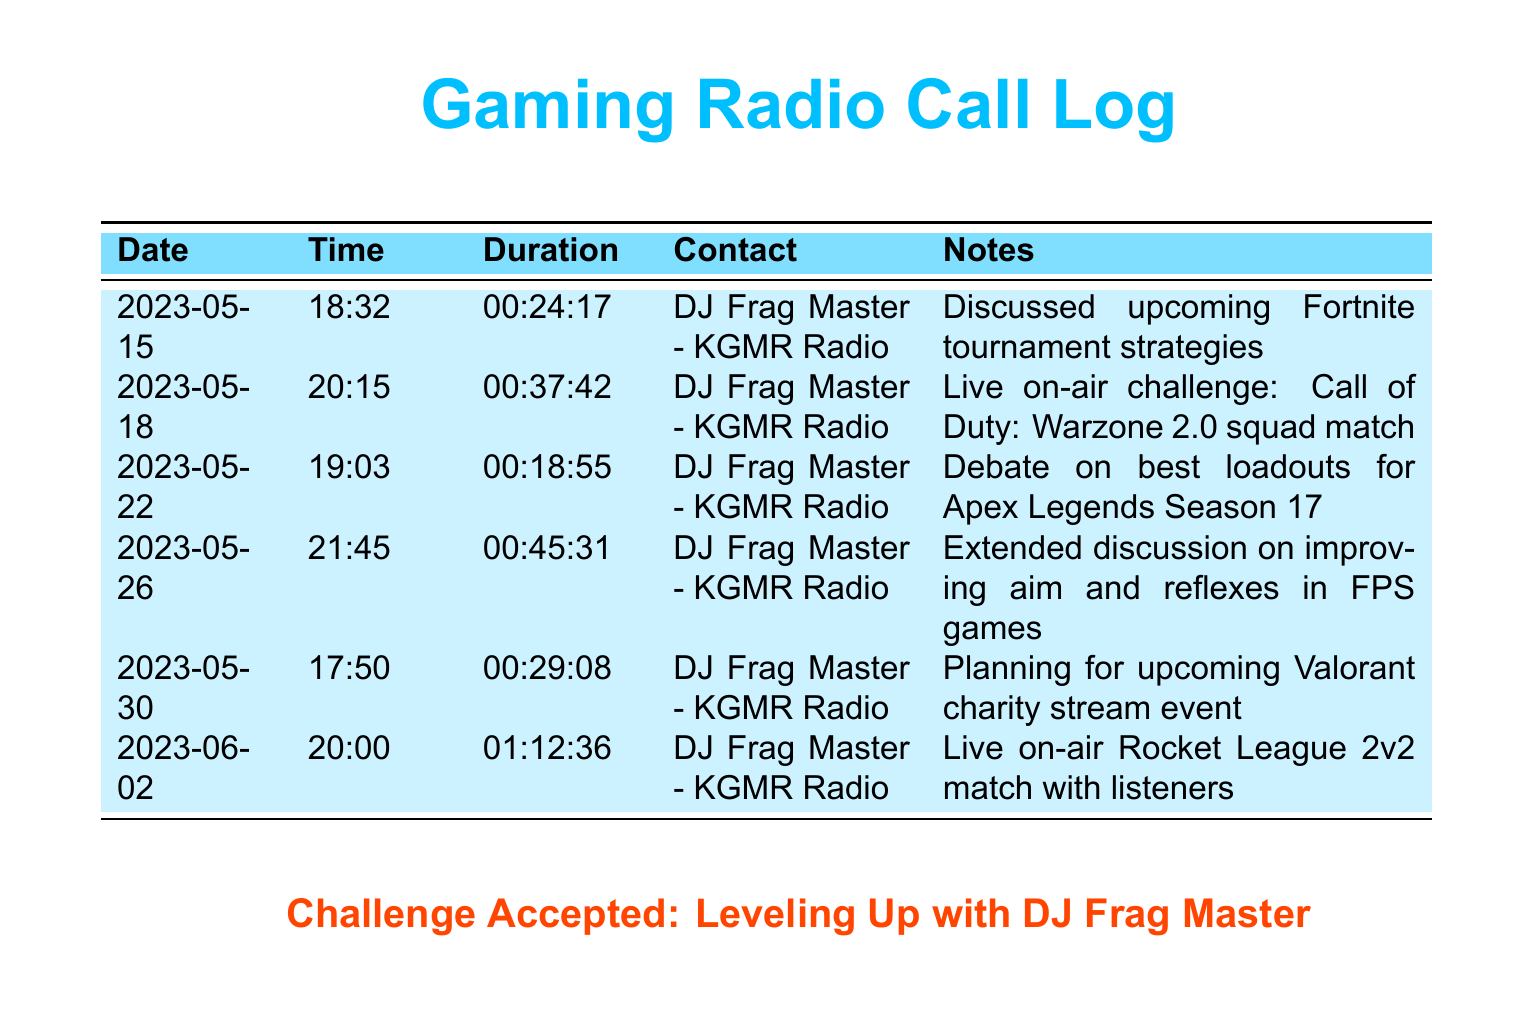What is the date of the first call? The first call occurred on May 15, 2023, as shown in the document.
Answer: May 15, 2023 Who is the contact for all calls? All calls are with DJ Frag Master from KGMR Radio, as stated in the records.
Answer: DJ Frag Master - KGMR Radio What was the duration of the longest call? The longest call lasted for one hour and twelve minutes and thirty-six seconds, which can be determined from the durations listed.
Answer: 01:12:36 How many calls were made in May 2023? There are five calls listed for May 2023, identified by the dates in the records.
Answer: 5 What game was discussed in the call on May 22? The call on May 22 discussed Apex Legends, as mentioned in the notes for that date.
Answer: Apex Legends Which call involved a live on-air match? The call on June 2 involved a live on-air Rocket League match, according to the entry details.
Answer: June 2 What was a common theme discussed in the calls? The common themes included strategies for games, as referenced in various notes throughout the calls.
Answer: Strategies for games What is the date of the last call? The last recorded call was made on June 2, 2023, according to the table.
Answer: June 2, 2023 